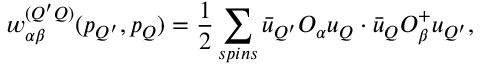Convert formula to latex. <formula><loc_0><loc_0><loc_500><loc_500>w _ { \alpha \beta } ^ { ( Q ^ { \prime } Q ) } ( p _ { Q ^ { \prime } } , p _ { Q } ) = \frac { 1 } { 2 } \sum _ { s p i n s } \bar { u } _ { Q ^ { \prime } } O _ { \alpha } u _ { Q } \cdot \bar { u } _ { Q } O _ { \beta } ^ { + } u _ { Q ^ { \prime } } ,</formula> 